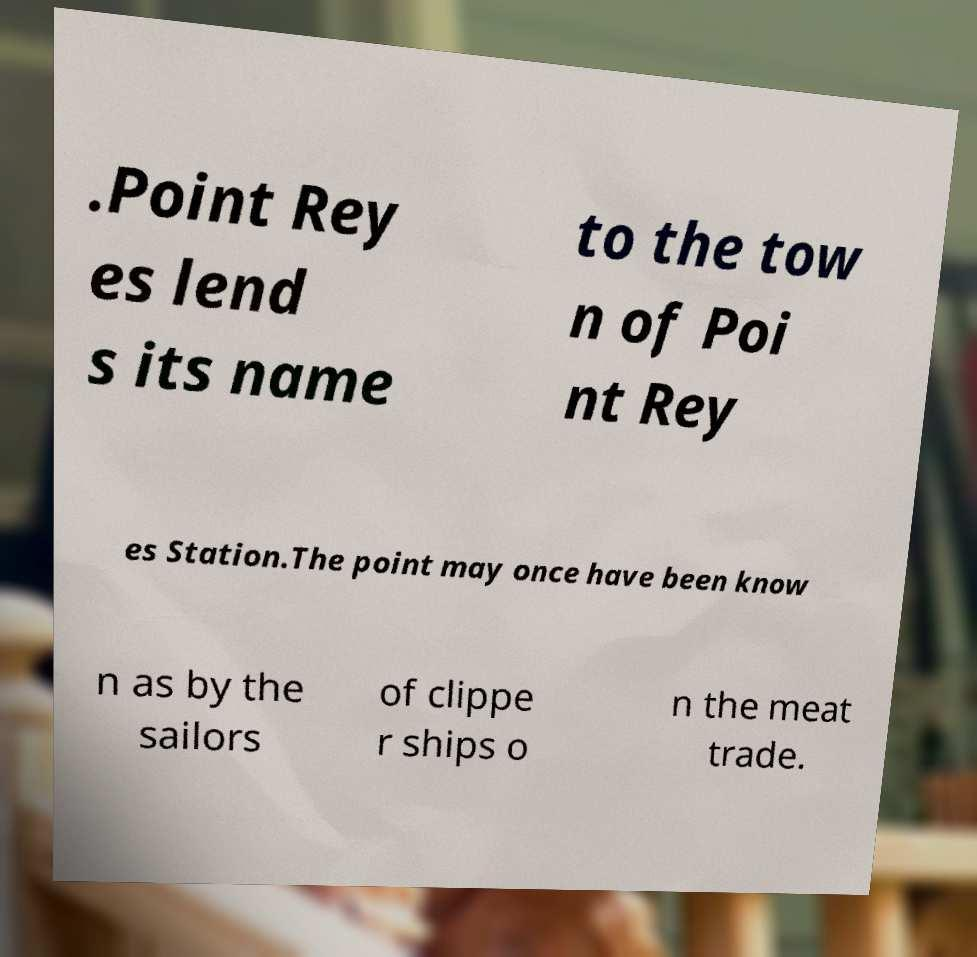Can you read and provide the text displayed in the image?This photo seems to have some interesting text. Can you extract and type it out for me? .Point Rey es lend s its name to the tow n of Poi nt Rey es Station.The point may once have been know n as by the sailors of clippe r ships o n the meat trade. 